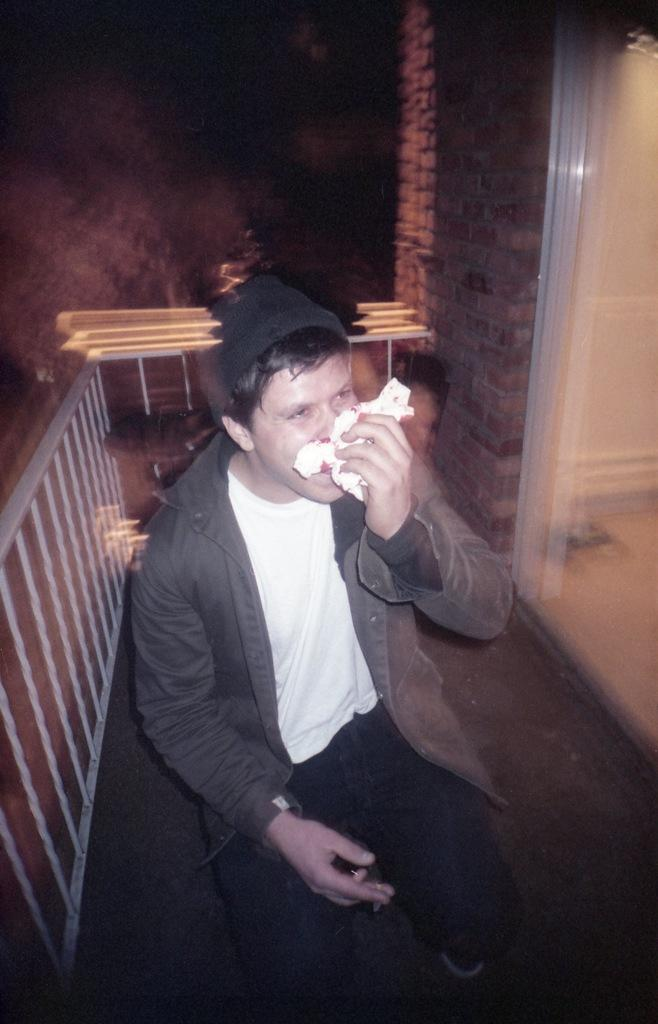What is the person in the image doing? The person is sitting in the image and covering their nose with a handkerchief. What can be seen in the background of the image? There are stairs and a wall visible in the background of the image. What type of town can be seen in the image? There is no town visible in the image; it only shows a person sitting and covering their nose with a handkerchief, along with stairs and a wall in the background. 